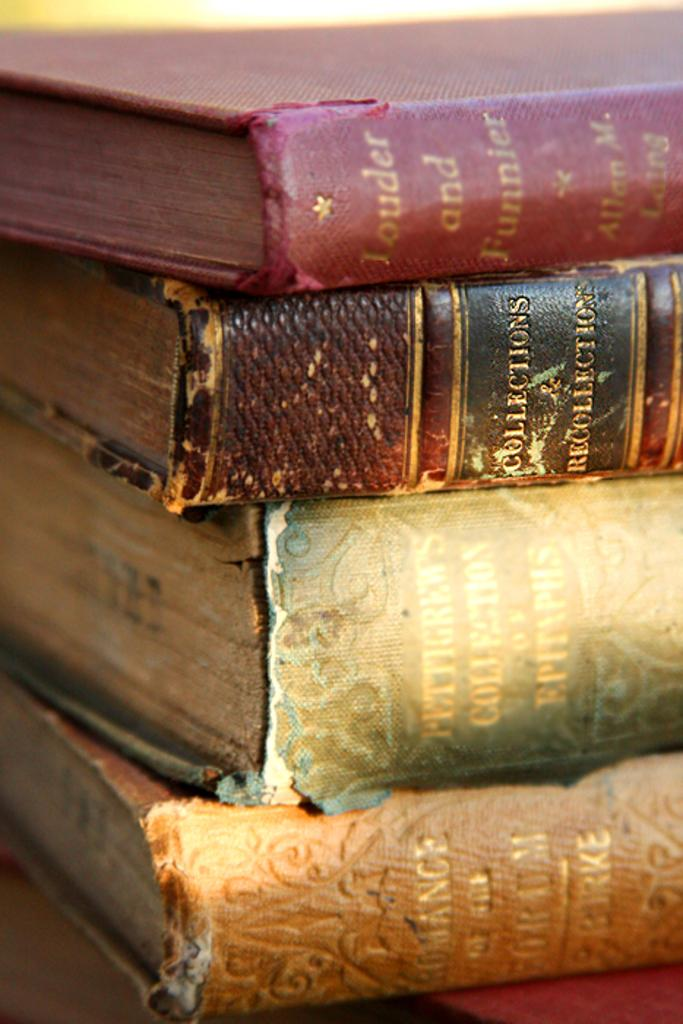<image>
Relay a brief, clear account of the picture shown. A stack of old books including Collections & Recollections. 